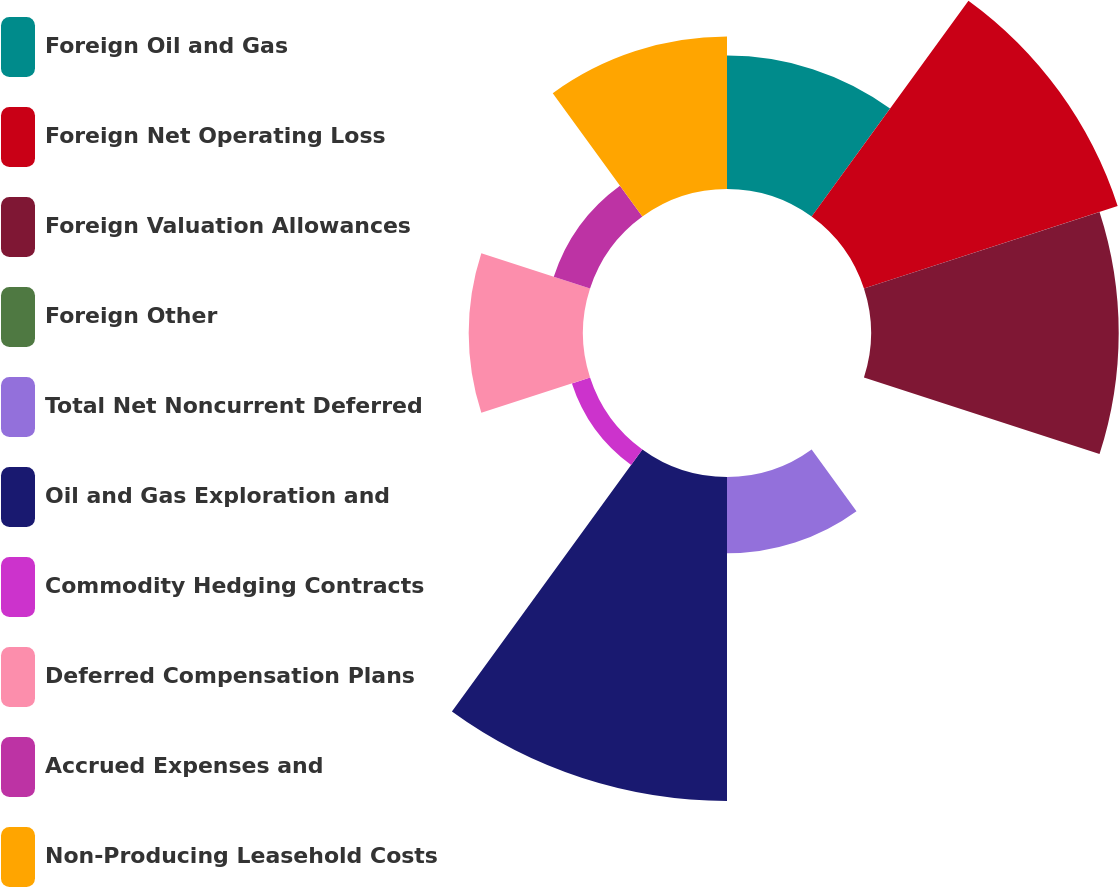<chart> <loc_0><loc_0><loc_500><loc_500><pie_chart><fcel>Foreign Oil and Gas<fcel>Foreign Net Operating Loss<fcel>Foreign Valuation Allowances<fcel>Foreign Other<fcel>Total Net Noncurrent Deferred<fcel>Oil and Gas Exploration and<fcel>Commodity Hedging Contracts<fcel>Deferred Compensation Plans<fcel>Accrued Expenses and<fcel>Non-Producing Leasehold Costs<nl><fcel>9.72%<fcel>19.44%<fcel>18.05%<fcel>0.0%<fcel>5.56%<fcel>23.61%<fcel>1.39%<fcel>8.33%<fcel>2.78%<fcel>11.11%<nl></chart> 